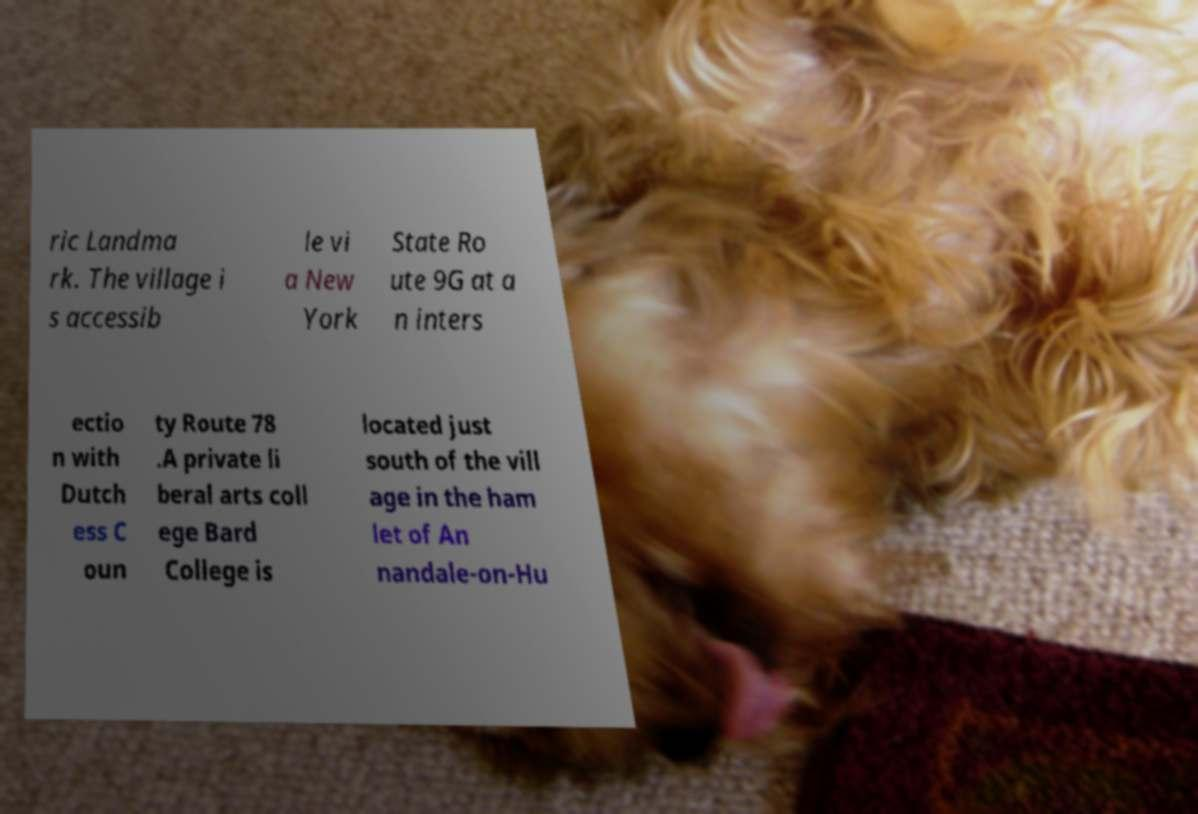Could you assist in decoding the text presented in this image and type it out clearly? ric Landma rk. The village i s accessib le vi a New York State Ro ute 9G at a n inters ectio n with Dutch ess C oun ty Route 78 .A private li beral arts coll ege Bard College is located just south of the vill age in the ham let of An nandale-on-Hu 